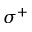<formula> <loc_0><loc_0><loc_500><loc_500>\sigma ^ { + }</formula> 